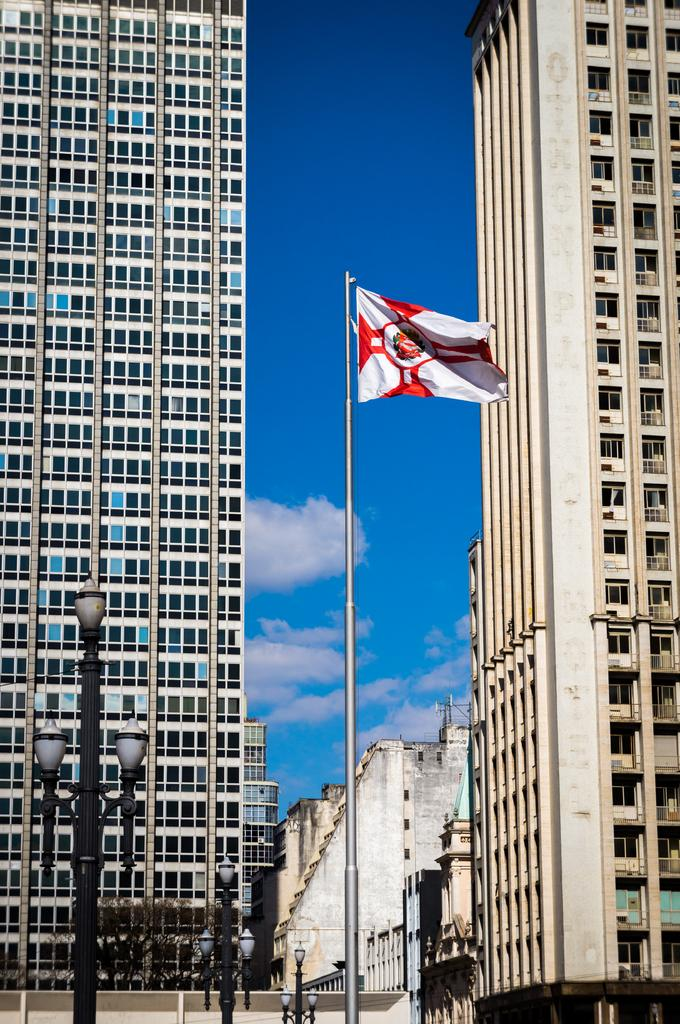What type of buildings can be seen on both sides of the image? There are two skyscrapers in the image, one on each side. What is located in the middle of the image? There is a flag in the middle of the image. What can be seen on the left side of the image besides the skyscraper? There is a street light on the left side of the image. What is visible in the background of the image? The sky is visible in the image, and clouds are present in the sky. What historical event is being commemorated by the bridge in the image? There is no bridge present in the image; it features two skyscrapers, a flag, and a street light. What does the image smell like? Images do not have a smell, as they are visual representations and not physical objects. 